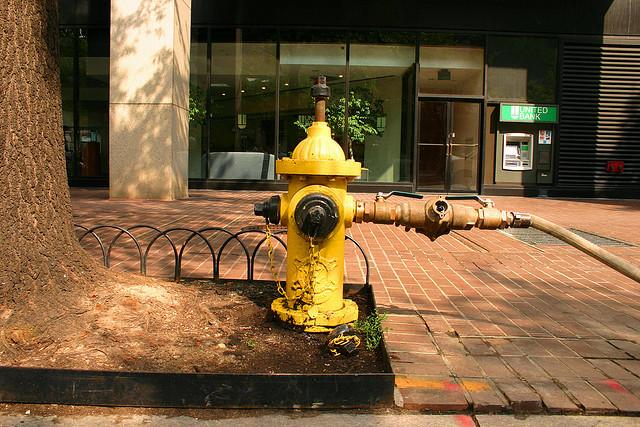Where can you get money from in this photo?
Quick response, please. Atm. What is to the left of the hydrant?
Write a very short answer. Tree. What is the color of the hydrant?
Write a very short answer. Yellow. 